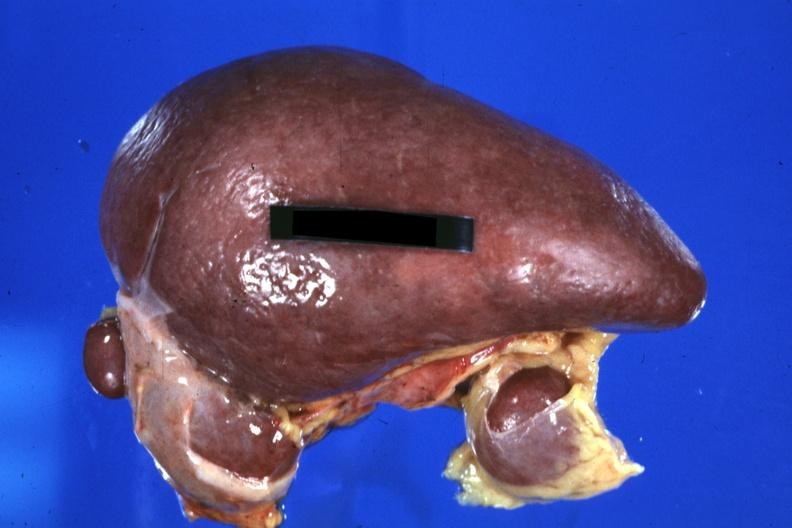does this image show spleen with three accessories 32yobf left isomerism and complex congenital heart disease?
Answer the question using a single word or phrase. Yes 